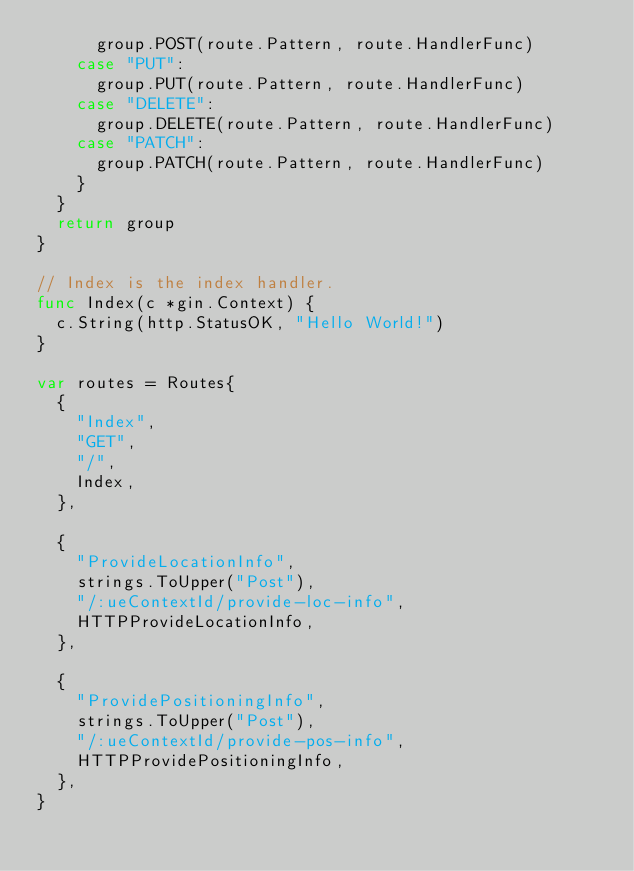<code> <loc_0><loc_0><loc_500><loc_500><_Go_>			group.POST(route.Pattern, route.HandlerFunc)
		case "PUT":
			group.PUT(route.Pattern, route.HandlerFunc)
		case "DELETE":
			group.DELETE(route.Pattern, route.HandlerFunc)
		case "PATCH":
			group.PATCH(route.Pattern, route.HandlerFunc)
		}
	}
	return group
}

// Index is the index handler.
func Index(c *gin.Context) {
	c.String(http.StatusOK, "Hello World!")
}

var routes = Routes{
	{
		"Index",
		"GET",
		"/",
		Index,
	},

	{
		"ProvideLocationInfo",
		strings.ToUpper("Post"),
		"/:ueContextId/provide-loc-info",
		HTTPProvideLocationInfo,
	},

	{
		"ProvidePositioningInfo",
		strings.ToUpper("Post"),
		"/:ueContextId/provide-pos-info",
		HTTPProvidePositioningInfo,
	},
}
</code> 